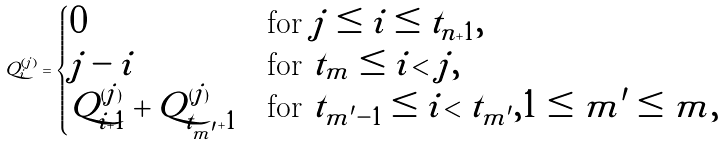Convert formula to latex. <formula><loc_0><loc_0><loc_500><loc_500>Q ^ { ( j ) } _ { i } = \begin{cases} 0 & \text {for $j \leq i \leq t_{n+1}$} , \\ j - i & \text {for $t_{m}\leq i<j$} , \\ Q ^ { ( j ) } _ { i + 1 } + Q ^ { ( j ) } _ { t _ { m ^ { \prime } } + 1 } & \text {for $t_{m^{\prime}-1}\leq i<t_{m^{\prime}},1\leq m^{\prime}\leq m$} , \end{cases}</formula> 